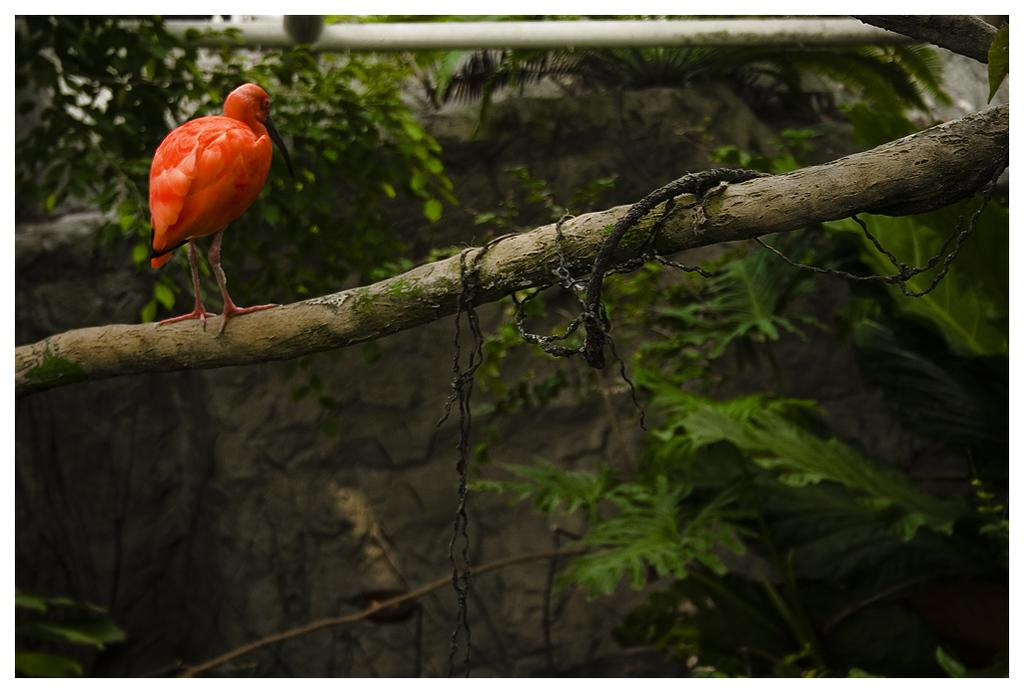What type of animal can be seen in the image? There is a bird in the image. Where is the bird located in the image? The bird is sitting on a stick. What type of vegetation is present in the image? A: There are green plants in the image. What type of sack is being used to carry the bird in the image? There is no sack present in the image; the bird is sitting on a stick. What process is being carried out by the bird in the image? The bird is simply sitting on a stick, and no specific process is being performed. 